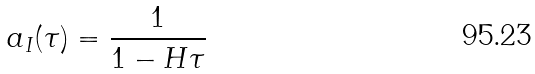<formula> <loc_0><loc_0><loc_500><loc_500>a _ { I } ( \tau ) = \frac { 1 } { 1 - H \tau }</formula> 